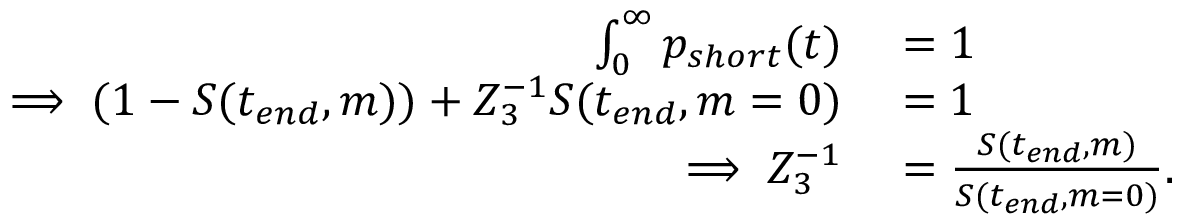Convert formula to latex. <formula><loc_0><loc_0><loc_500><loc_500>\begin{array} { r l } { \int _ { 0 } ^ { \infty } p _ { s h o r t } ( t ) } & = 1 } \\ { \implies ( 1 - S ( t _ { e n d } , m ) ) + Z _ { 3 } ^ { - 1 } S ( t _ { e n d } , m = 0 ) } & = 1 } \\ { \implies Z _ { 3 } ^ { - 1 } } & = \frac { S ( t _ { e n d } , m ) } { S ( t _ { e n d } , m = 0 ) } . } \end{array}</formula> 